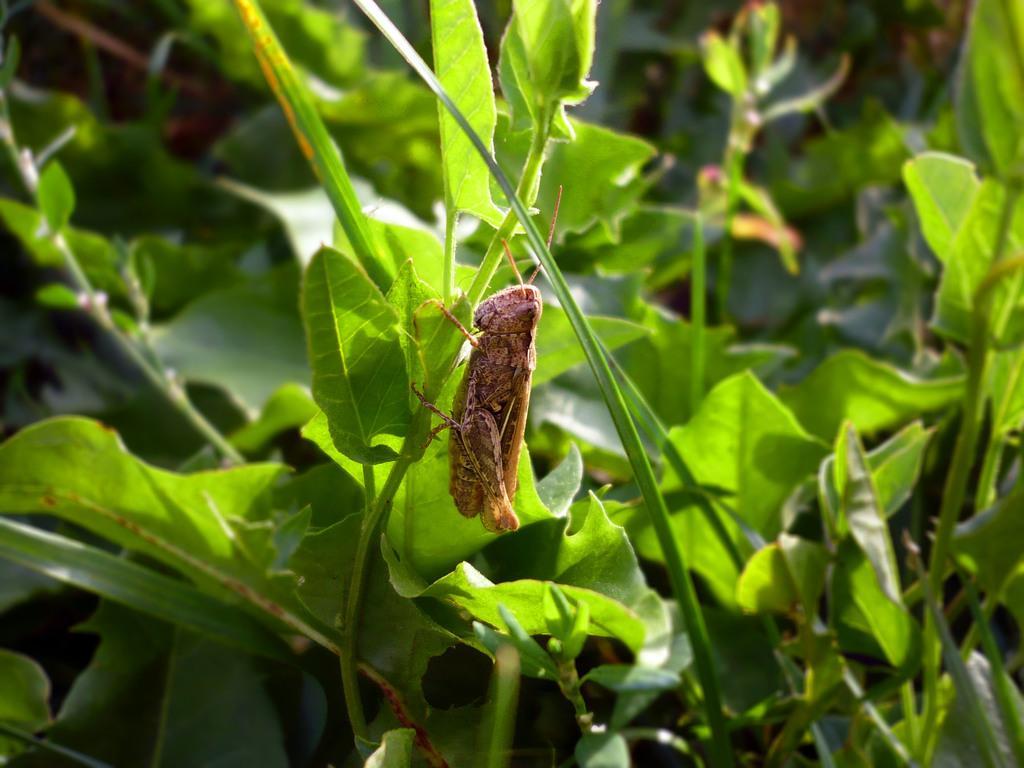Could you give a brief overview of what you see in this image? In the image I can see an insect which is brown in color to a plant which is green in color. I can see few other plants which are green in color. 